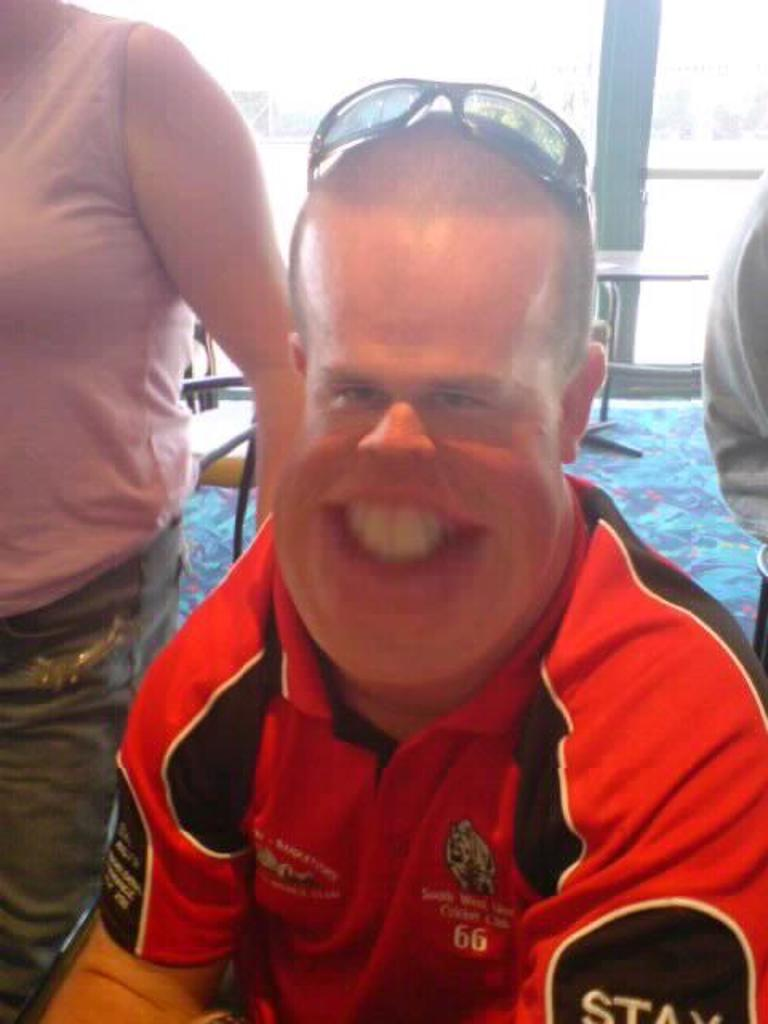What is the person in the image doing? The person in the image is sitting on a chair. Are there any other people in the image? Yes, there are two people standing on either side of the sitting person. What can be seen in the background of the image? There is a table and a pole in the background of the image. What type of juice is being served on the table in the image? There is no juice present in the image; only a table and a pole can be seen in the background. 